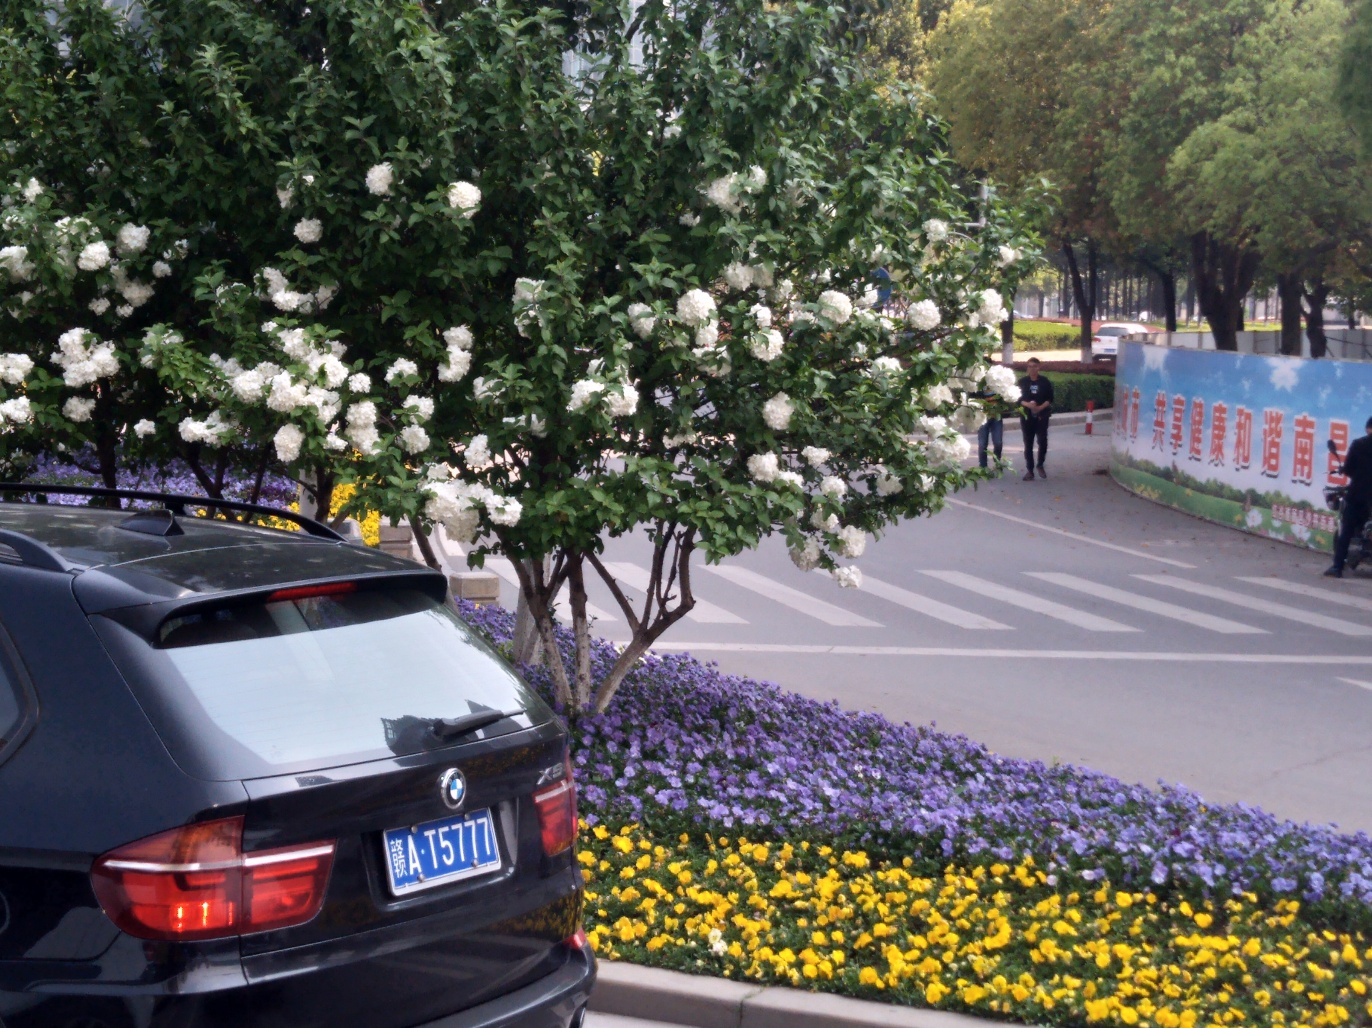Could you describe the setting of this image? Certainly. This image depicts an urban scene with a focus on horticulture. A variety of colorful flowers have been planted in neat beds, separated by paved paths. There is a car parked to the left and a pedestrian walking in the background. In the distance, trees and banners with writing can be seen, contributing to the lively atmosphere of a city space that prioritizes greenery and public beauty. 